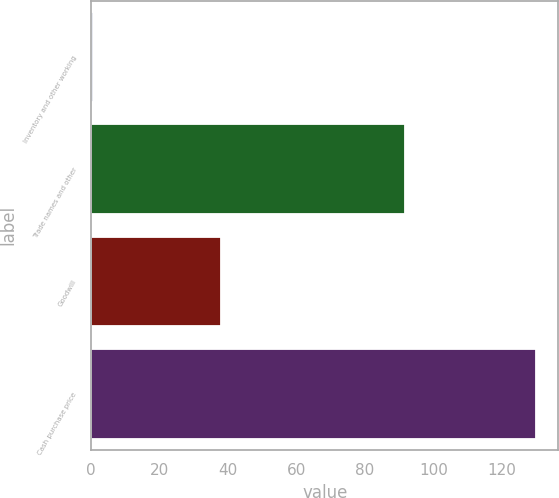Convert chart to OTSL. <chart><loc_0><loc_0><loc_500><loc_500><bar_chart><fcel>Inventory and other working<fcel>Trade names and other<fcel>Goodwill<fcel>Cash purchase price<nl><fcel>0.5<fcel>91.7<fcel>37.8<fcel>130<nl></chart> 